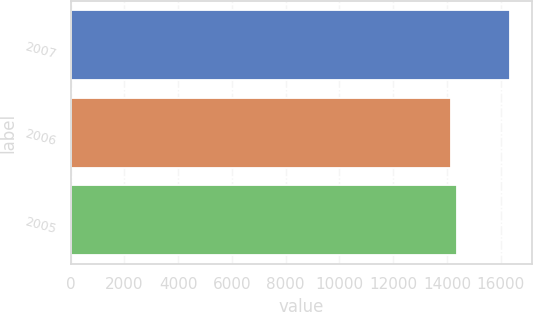Convert chart to OTSL. <chart><loc_0><loc_0><loc_500><loc_500><bar_chart><fcel>2007<fcel>2006<fcel>2005<nl><fcel>16351<fcel>14164<fcel>14382.7<nl></chart> 